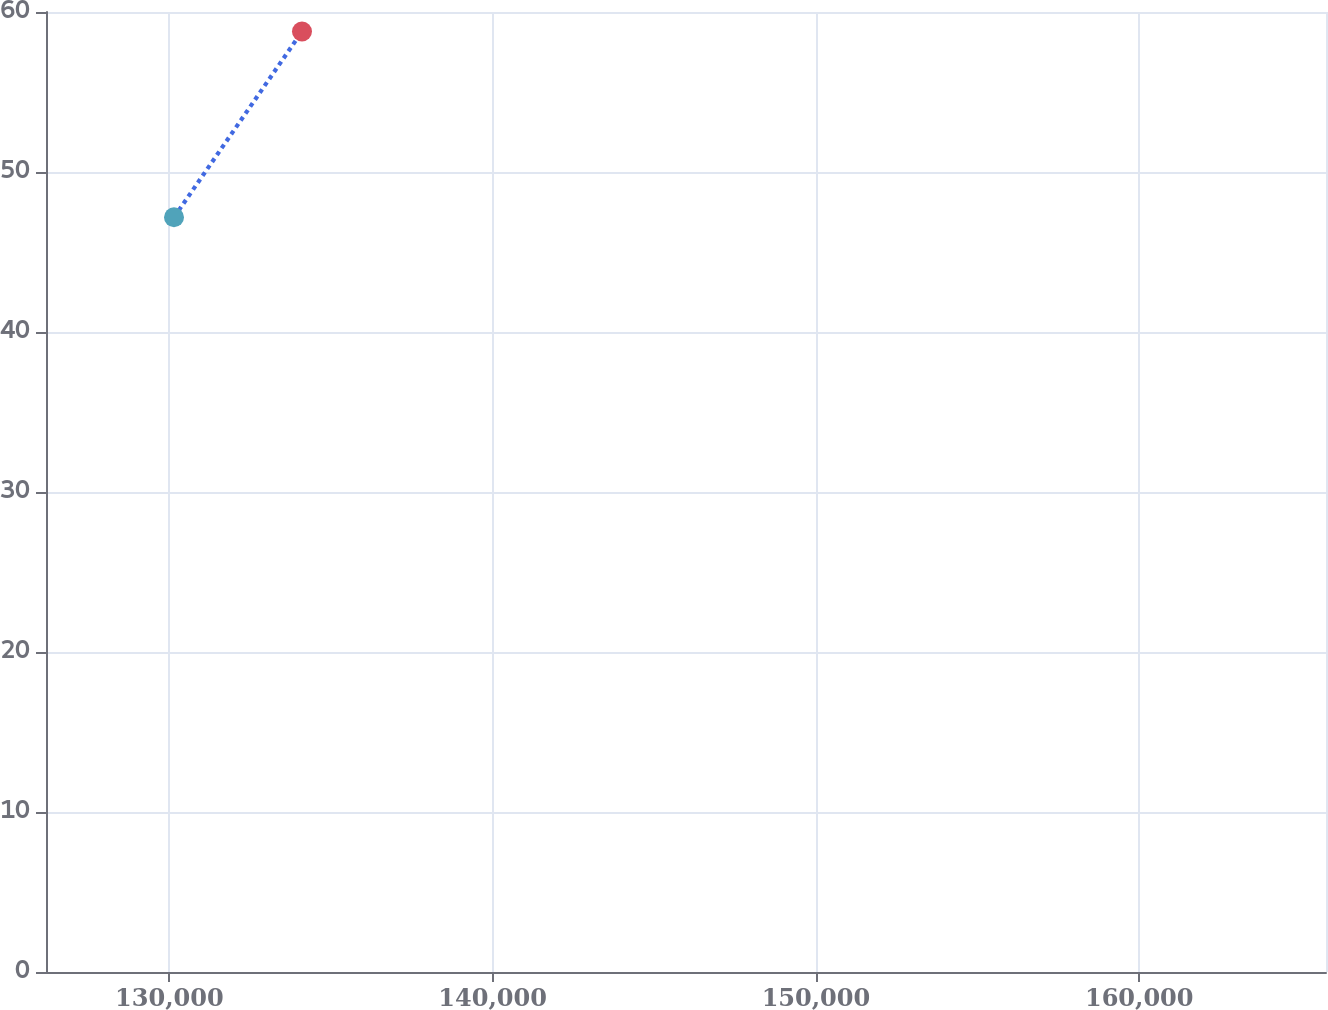Convert chart. <chart><loc_0><loc_0><loc_500><loc_500><line_chart><ecel><fcel>Weighted- Average  Grant Date  Fair Value  Per Share<nl><fcel>130145<fcel>47.17<nl><fcel>134104<fcel>58.78<nl><fcel>169737<fcel>57.67<nl></chart> 